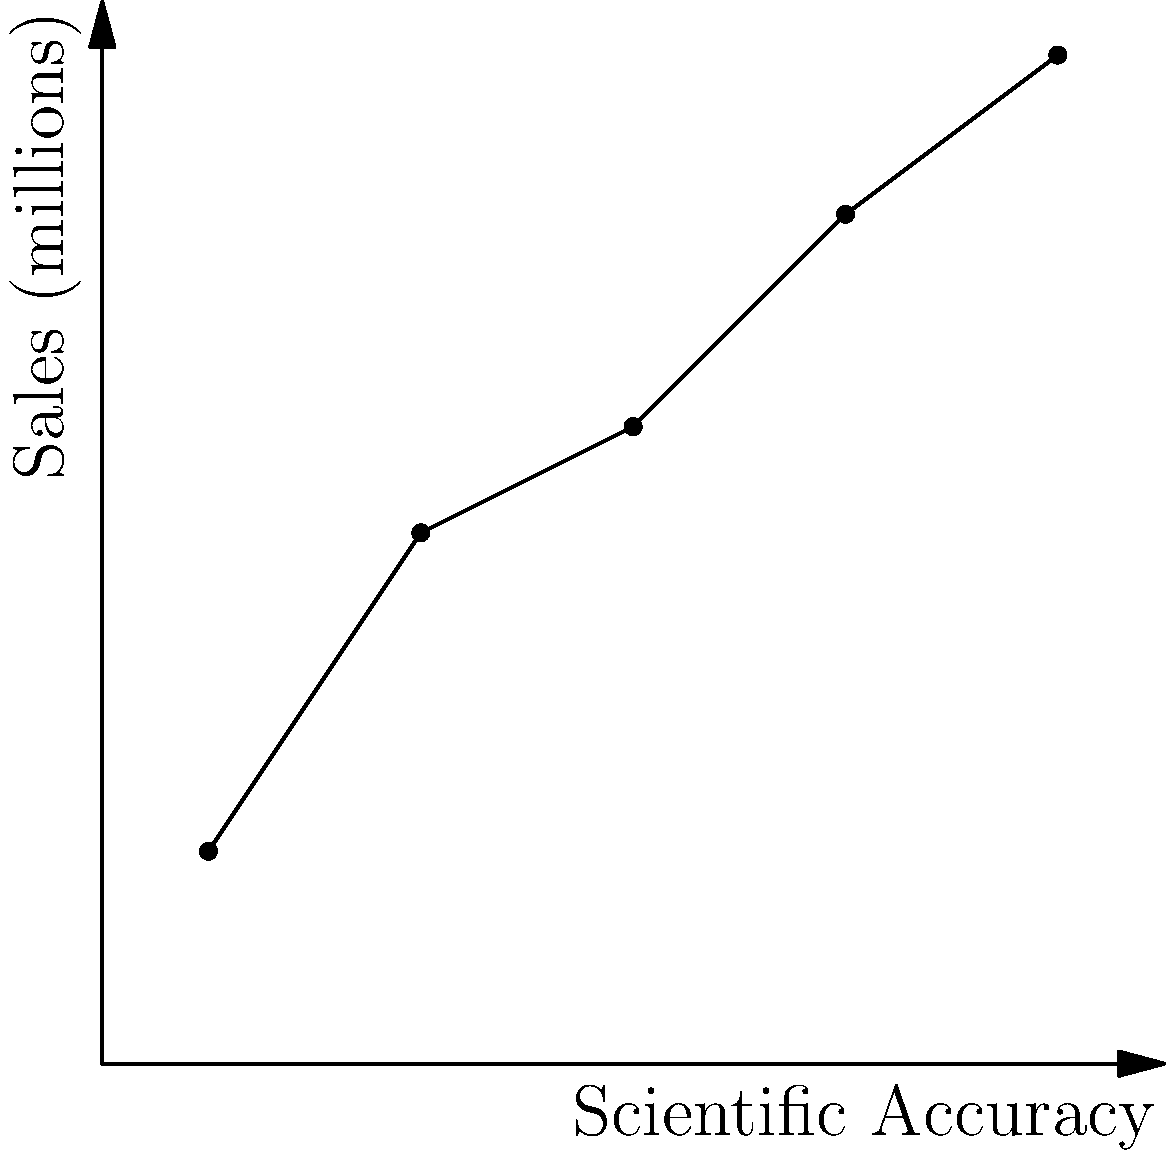Analyze the scatter plot representing the correlation between a book's scientific accuracy and its sales. What trend does this graph suggest about the relationship between scientific accuracy in literature and commercial success? To analyze the trend in the scatter plot:

1. Observe the overall pattern: The points generally move from the bottom-left to the top-right of the graph.

2. Interpret the axes:
   - X-axis represents scientific accuracy (0 to 1)
   - Y-axis represents sales in millions (0 to 1)

3. Analyze the correlation:
   - As scientific accuracy increases, sales tend to increase.
   - This suggests a positive correlation between scientific accuracy and sales.

4. Consider the strength of the correlation:
   - The points form a relatively straight line with minimal scatter.
   - This indicates a strong positive correlation.

5. Interpret the literary implications:
   - Books with higher scientific accuracy tend to sell better.
   - This suggests that readers may value scientific accuracy in contemporary literature.

6. Consider potential factors:
   - Increased public interest in STEM topics
   - Growing emphasis on scientific literacy in society
   - Possible preference for well-researched, accurate narratives

The trend suggests that in contemporary literature, there is a strong positive correlation between a book's scientific accuracy and its commercial success.
Answer: Strong positive correlation between scientific accuracy and sales 